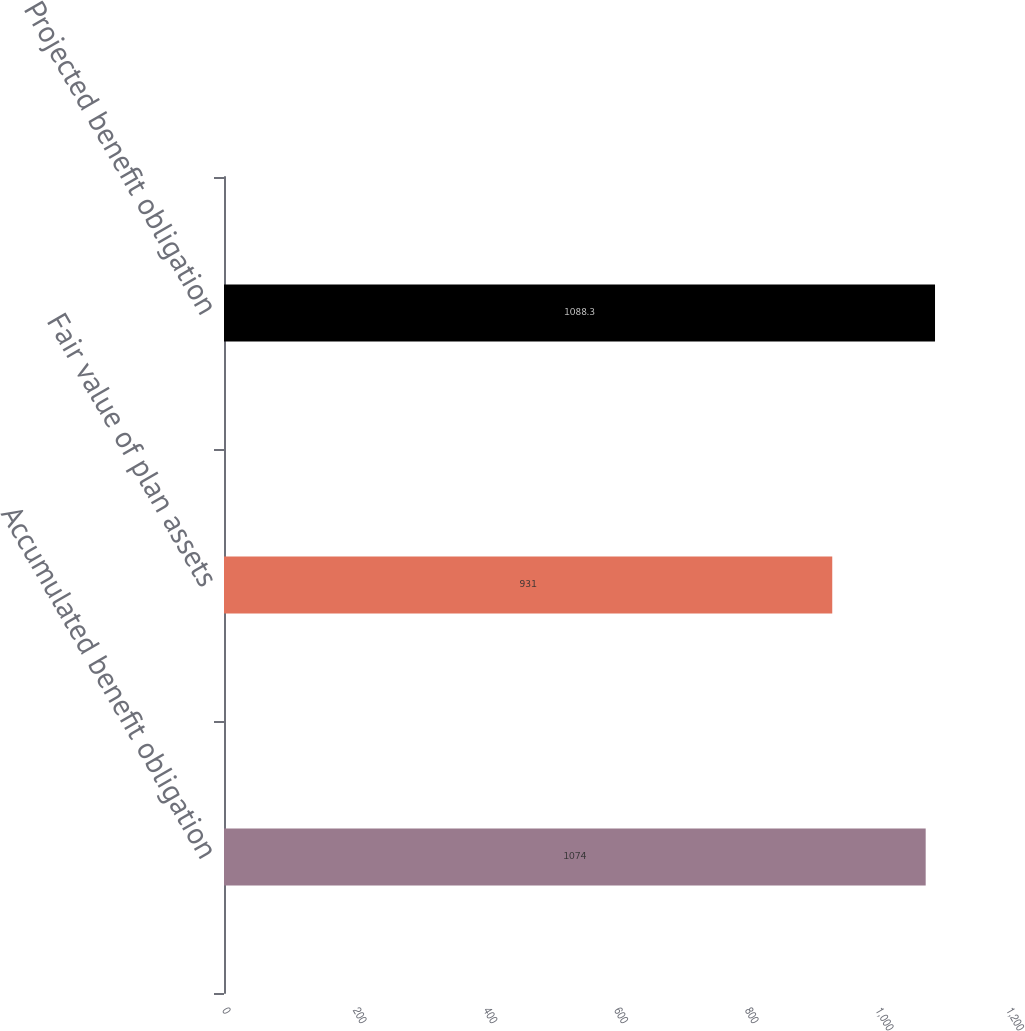<chart> <loc_0><loc_0><loc_500><loc_500><bar_chart><fcel>Accumulated benefit obligation<fcel>Fair value of plan assets<fcel>Projected benefit obligation<nl><fcel>1074<fcel>931<fcel>1088.3<nl></chart> 